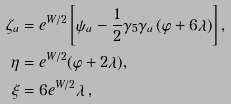<formula> <loc_0><loc_0><loc_500><loc_500>\zeta _ { a } & = e ^ { W / 2 } \left [ \psi _ { a } - \frac { 1 } { 2 } \gamma _ { 5 } \gamma _ { a } \left ( \varphi + 6 \lambda \right ) \right ] , \\ \eta & = e ^ { W / 2 } ( \varphi + 2 \lambda ) , \\ \xi & = 6 e ^ { W / 2 } \lambda \, ,</formula> 